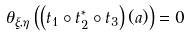<formula> <loc_0><loc_0><loc_500><loc_500>\theta _ { \xi , \eta } \left ( \left ( t _ { 1 } \circ t _ { 2 } ^ { * } \circ t _ { 3 } \right ) ( a ) \right ) = 0</formula> 